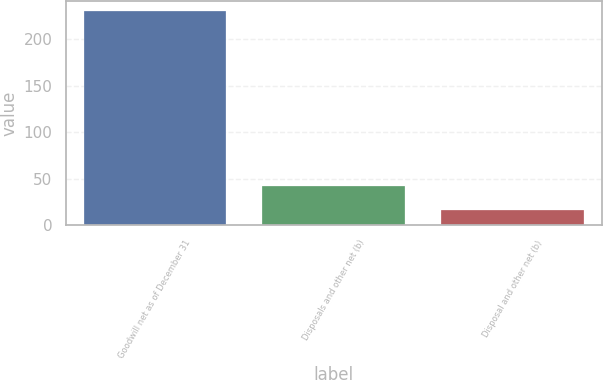<chart> <loc_0><loc_0><loc_500><loc_500><bar_chart><fcel>Goodwill net as of December 31<fcel>Disposals and other net (b)<fcel>Disposal and other net (b)<nl><fcel>230<fcel>42.1<fcel>17<nl></chart> 